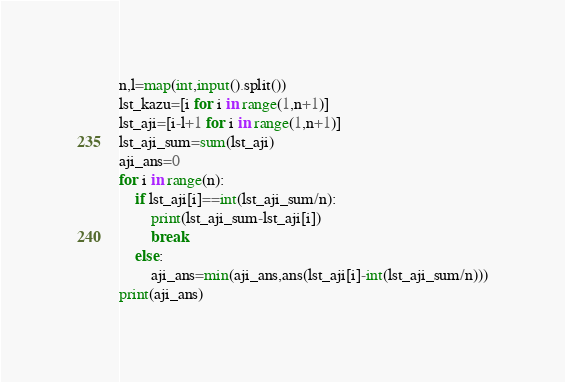Convert code to text. <code><loc_0><loc_0><loc_500><loc_500><_Python_>n,l=map(int,input().split())
lst_kazu=[i for i in range(1,n+1)]
lst_aji=[i-l+1 for i in range(1,n+1)]
lst_aji_sum=sum(lst_aji)
aji_ans=0
for i in range(n):
	if lst_aji[i]==int(lst_aji_sum/n):
    	print(lst_aji_sum-lst_aji[i])
        break
    else:
      	aji_ans=min(aji_ans,ans(lst_aji[i]-int(lst_aji_sum/n)))
print(aji_ans)</code> 